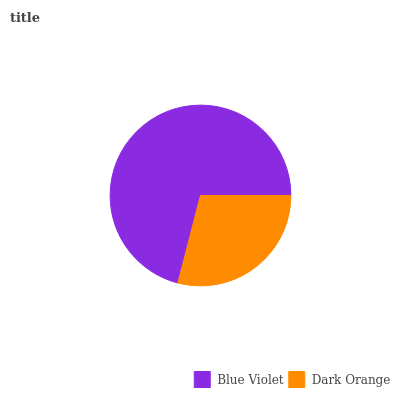Is Dark Orange the minimum?
Answer yes or no. Yes. Is Blue Violet the maximum?
Answer yes or no. Yes. Is Dark Orange the maximum?
Answer yes or no. No. Is Blue Violet greater than Dark Orange?
Answer yes or no. Yes. Is Dark Orange less than Blue Violet?
Answer yes or no. Yes. Is Dark Orange greater than Blue Violet?
Answer yes or no. No. Is Blue Violet less than Dark Orange?
Answer yes or no. No. Is Blue Violet the high median?
Answer yes or no. Yes. Is Dark Orange the low median?
Answer yes or no. Yes. Is Dark Orange the high median?
Answer yes or no. No. Is Blue Violet the low median?
Answer yes or no. No. 